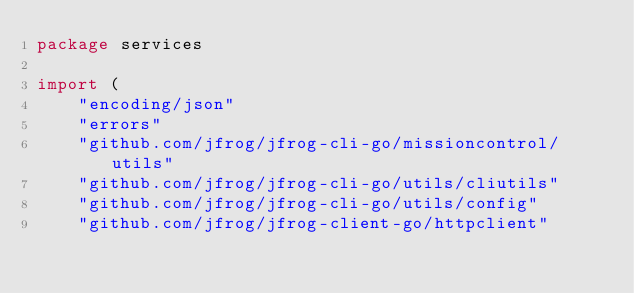<code> <loc_0><loc_0><loc_500><loc_500><_Go_>package services

import (
	"encoding/json"
	"errors"
	"github.com/jfrog/jfrog-cli-go/missioncontrol/utils"
	"github.com/jfrog/jfrog-cli-go/utils/cliutils"
	"github.com/jfrog/jfrog-cli-go/utils/config"
	"github.com/jfrog/jfrog-client-go/httpclient"</code> 